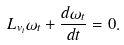<formula> <loc_0><loc_0><loc_500><loc_500>L _ { v _ { t } } \omega _ { t } + \frac { d \omega _ { t } } { d t } = 0 .</formula> 